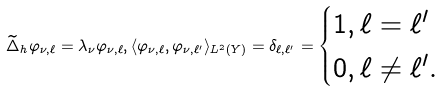Convert formula to latex. <formula><loc_0><loc_0><loc_500><loc_500>\widetilde { \Delta } _ { h } \varphi _ { \nu , \ell } = \lambda _ { \nu } \varphi _ { \nu , \ell } , \langle \varphi _ { \nu , \ell } , \varphi _ { \nu , \ell ^ { \prime } } \rangle _ { L ^ { 2 } ( Y ) } = \delta _ { \ell , \ell ^ { \prime } } = \begin{cases} 1 , \ell = \ell ^ { \prime } \\ 0 , \ell \neq \ell ^ { \prime } . \end{cases}</formula> 